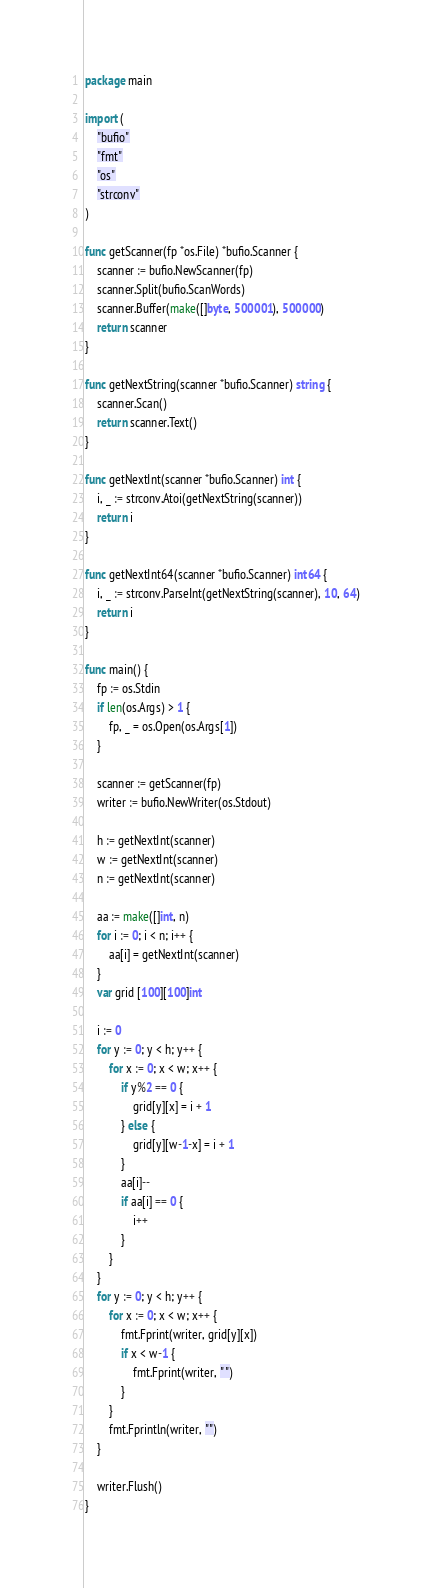<code> <loc_0><loc_0><loc_500><loc_500><_Go_>package main

import (
	"bufio"
	"fmt"
	"os"
	"strconv"
)

func getScanner(fp *os.File) *bufio.Scanner {
	scanner := bufio.NewScanner(fp)
	scanner.Split(bufio.ScanWords)
	scanner.Buffer(make([]byte, 500001), 500000)
	return scanner
}

func getNextString(scanner *bufio.Scanner) string {
	scanner.Scan()
	return scanner.Text()
}

func getNextInt(scanner *bufio.Scanner) int {
	i, _ := strconv.Atoi(getNextString(scanner))
	return i
}

func getNextInt64(scanner *bufio.Scanner) int64 {
	i, _ := strconv.ParseInt(getNextString(scanner), 10, 64)
	return i
}

func main() {
	fp := os.Stdin
	if len(os.Args) > 1 {
		fp, _ = os.Open(os.Args[1])
	}

	scanner := getScanner(fp)
	writer := bufio.NewWriter(os.Stdout)

	h := getNextInt(scanner)
	w := getNextInt(scanner)
	n := getNextInt(scanner)

	aa := make([]int, n)
	for i := 0; i < n; i++ {
		aa[i] = getNextInt(scanner)
	}
	var grid [100][100]int

	i := 0
	for y := 0; y < h; y++ {
		for x := 0; x < w; x++ {
			if y%2 == 0 {
				grid[y][x] = i + 1
			} else {
				grid[y][w-1-x] = i + 1
			}
			aa[i]--
			if aa[i] == 0 {
				i++
			}
		}
	}
	for y := 0; y < h; y++ {
		for x := 0; x < w; x++ {
			fmt.Fprint(writer, grid[y][x])
			if x < w-1 {
				fmt.Fprint(writer, " ")
			}
		}
		fmt.Fprintln(writer, "")
	}

	writer.Flush()
}
</code> 